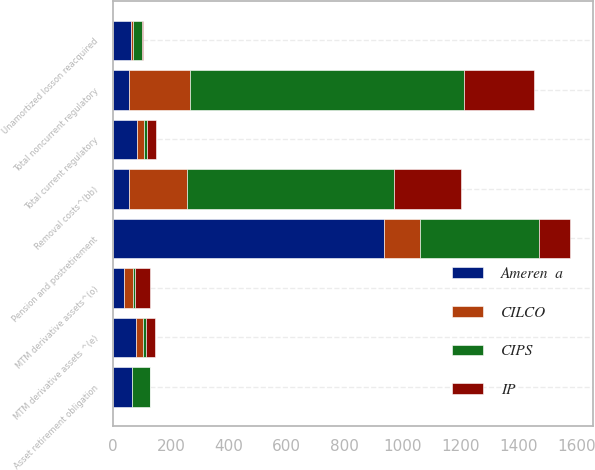Convert chart to OTSL. <chart><loc_0><loc_0><loc_500><loc_500><stacked_bar_chart><ecel><fcel>Removal costs^(bb)<fcel>Total noncurrent regulatory<fcel>MTM derivative assets ^(e)<fcel>Total current regulatory<fcel>Pension and postretirement<fcel>Asset retirement obligation<fcel>Unamortized losson reacquired<fcel>MTM derivative assets^(o)<nl><fcel>Ameren  a<fcel>56<fcel>56<fcel>79<fcel>82<fcel>936<fcel>65<fcel>63<fcel>39<nl><fcel>CIPS<fcel>716<fcel>947<fcel>10<fcel>10<fcel>410<fcel>60<fcel>30<fcel>6<nl><fcel>IP<fcel>231<fcel>242<fcel>30<fcel>32<fcel>107<fcel>2<fcel>5<fcel>52<nl><fcel>CILCO<fcel>199<fcel>209<fcel>24<fcel>24<fcel>125<fcel>1<fcel>5<fcel>30<nl></chart> 